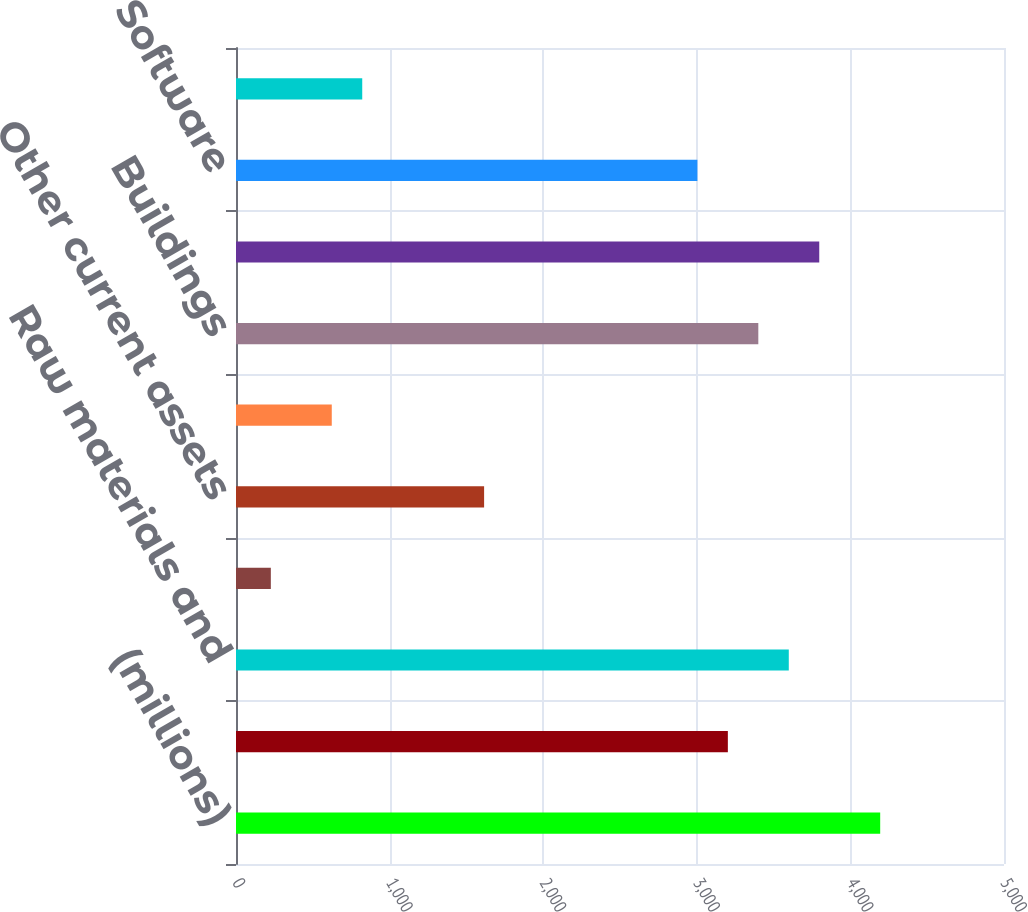<chart> <loc_0><loc_0><loc_500><loc_500><bar_chart><fcel>(millions)<fcel>Finished products<fcel>Raw materials and<fcel>Prepaid expenses<fcel>Other current assets<fcel>Land and improvements<fcel>Buildings<fcel>Machinery and equipment<fcel>Software<fcel>Construction-in-progress<nl><fcel>4193.96<fcel>3202.16<fcel>3598.88<fcel>226.76<fcel>1615.28<fcel>623.48<fcel>3400.52<fcel>3797.24<fcel>3003.8<fcel>821.84<nl></chart> 